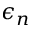Convert formula to latex. <formula><loc_0><loc_0><loc_500><loc_500>\epsilon _ { n }</formula> 